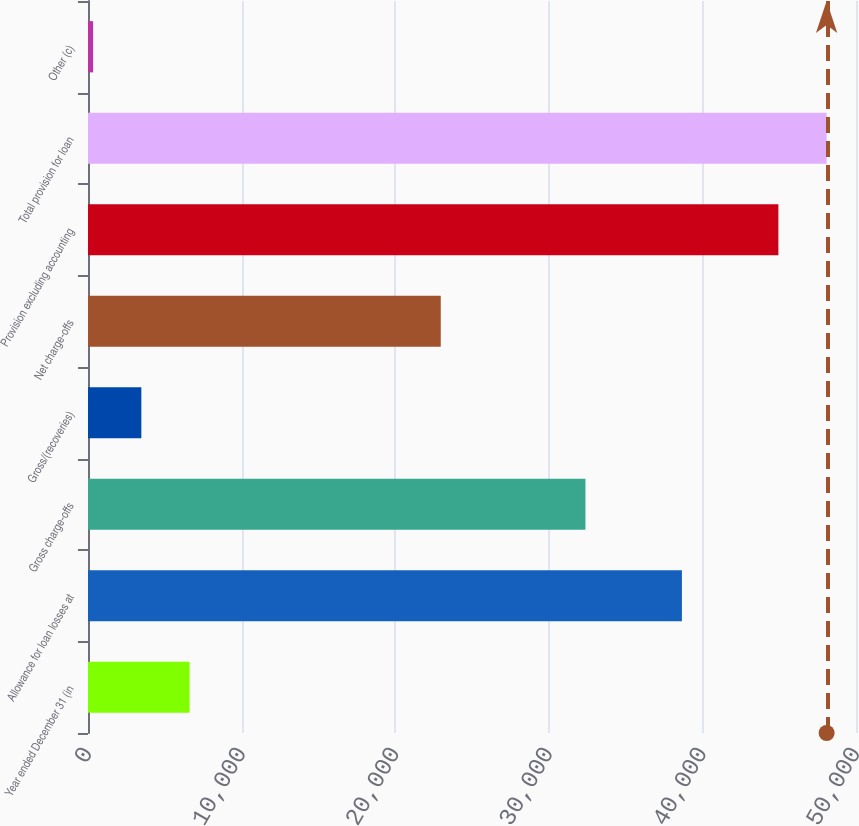Convert chart to OTSL. <chart><loc_0><loc_0><loc_500><loc_500><bar_chart><fcel>Year ended December 31 (in<fcel>Allowance for loan losses at<fcel>Gross charge-offs<fcel>Gross/(recoveries)<fcel>Net charge-offs<fcel>Provision excluding accounting<fcel>Total provision for loan<fcel>Other (c)<nl><fcel>6612.6<fcel>38666.5<fcel>32385.9<fcel>3472.3<fcel>22965<fcel>44947.1<fcel>48087.4<fcel>332<nl></chart> 